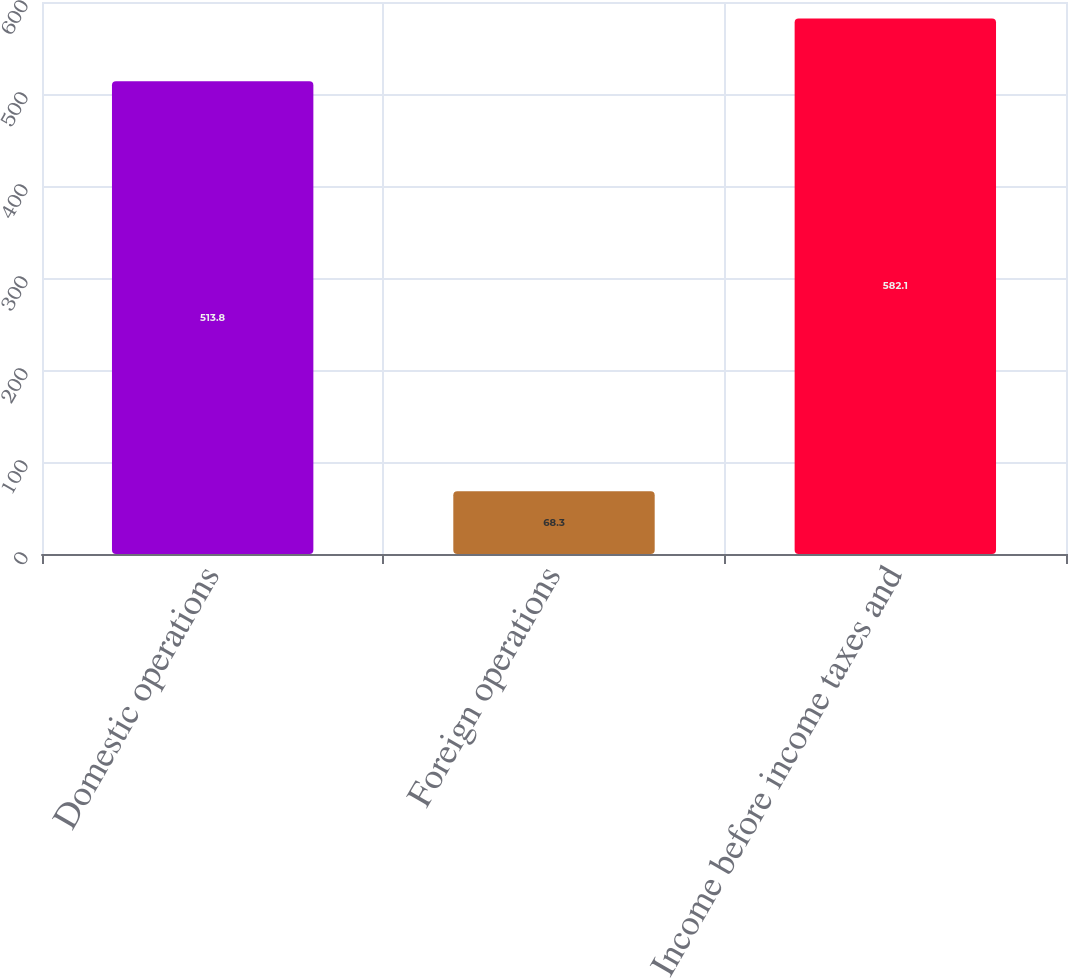Convert chart to OTSL. <chart><loc_0><loc_0><loc_500><loc_500><bar_chart><fcel>Domestic operations<fcel>Foreign operations<fcel>Income before income taxes and<nl><fcel>513.8<fcel>68.3<fcel>582.1<nl></chart> 